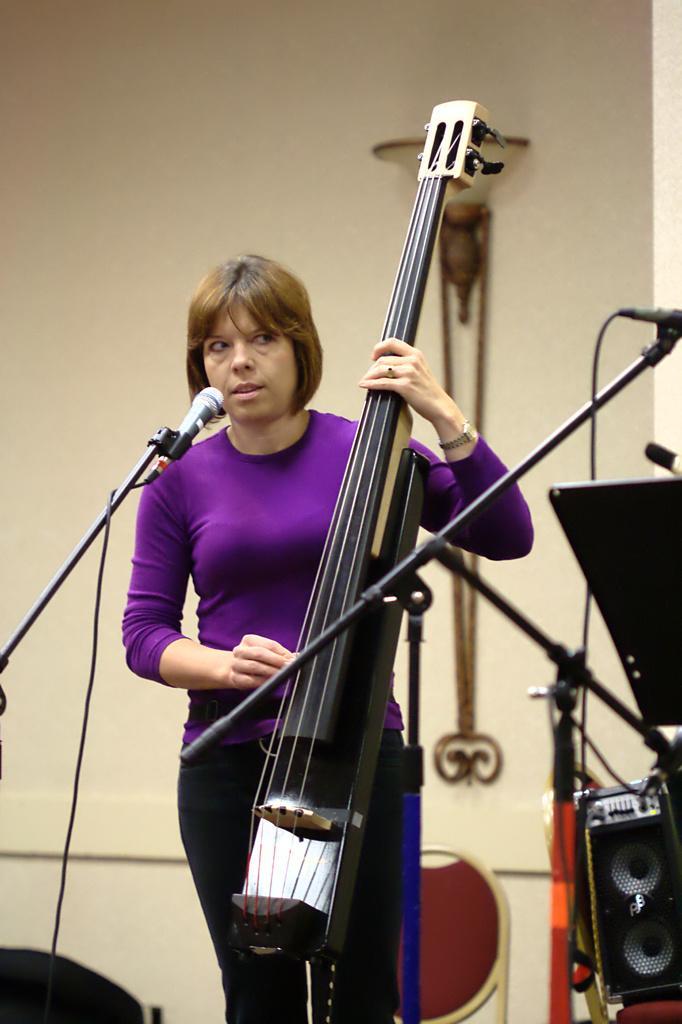Please provide a concise description of this image. In this image we can see a woman holding a musical instrument with her hands. In the background, we can see microphones placed on stands, speaker, board, chair placed on the ground and a lamp on the wall. 